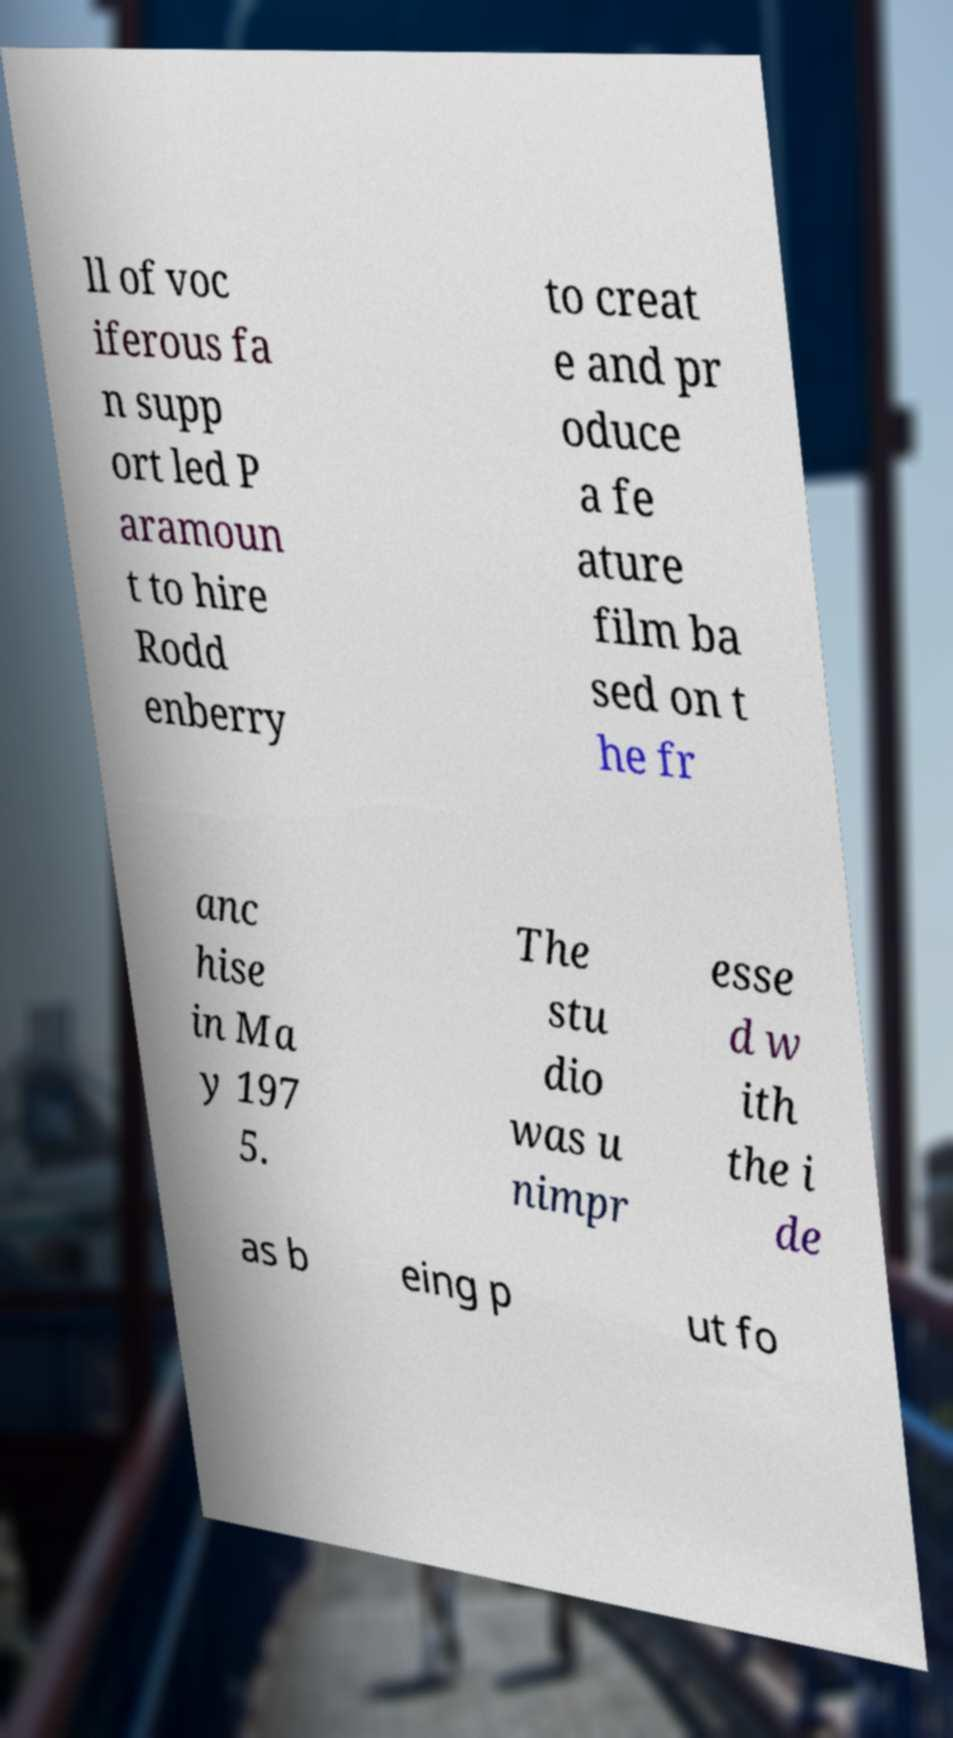Can you accurately transcribe the text from the provided image for me? ll of voc iferous fa n supp ort led P aramoun t to hire Rodd enberry to creat e and pr oduce a fe ature film ba sed on t he fr anc hise in Ma y 197 5. The stu dio was u nimpr esse d w ith the i de as b eing p ut fo 